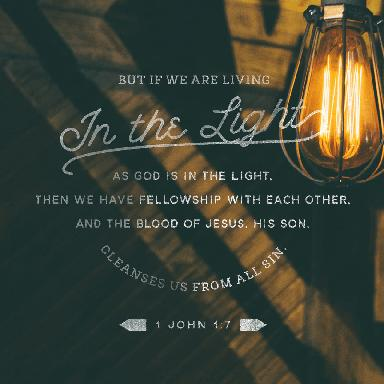What is the verse mentioned in the image?
 The verse mentioned in the image is 1 John 1:7. What is the message of this verse? The message of 1 John 1:7 is that if we live in the light as God is in the light, we have fellowship with one another, and the blood of Jesus, His Son, cleanses us from all sin. This verse emphasizes the importance of living in the light (symbolizing righteousness, truth, and a close relationship with God) and its benefits, such as fellowship with others and forgiveness of sins through Jesus Christ. 